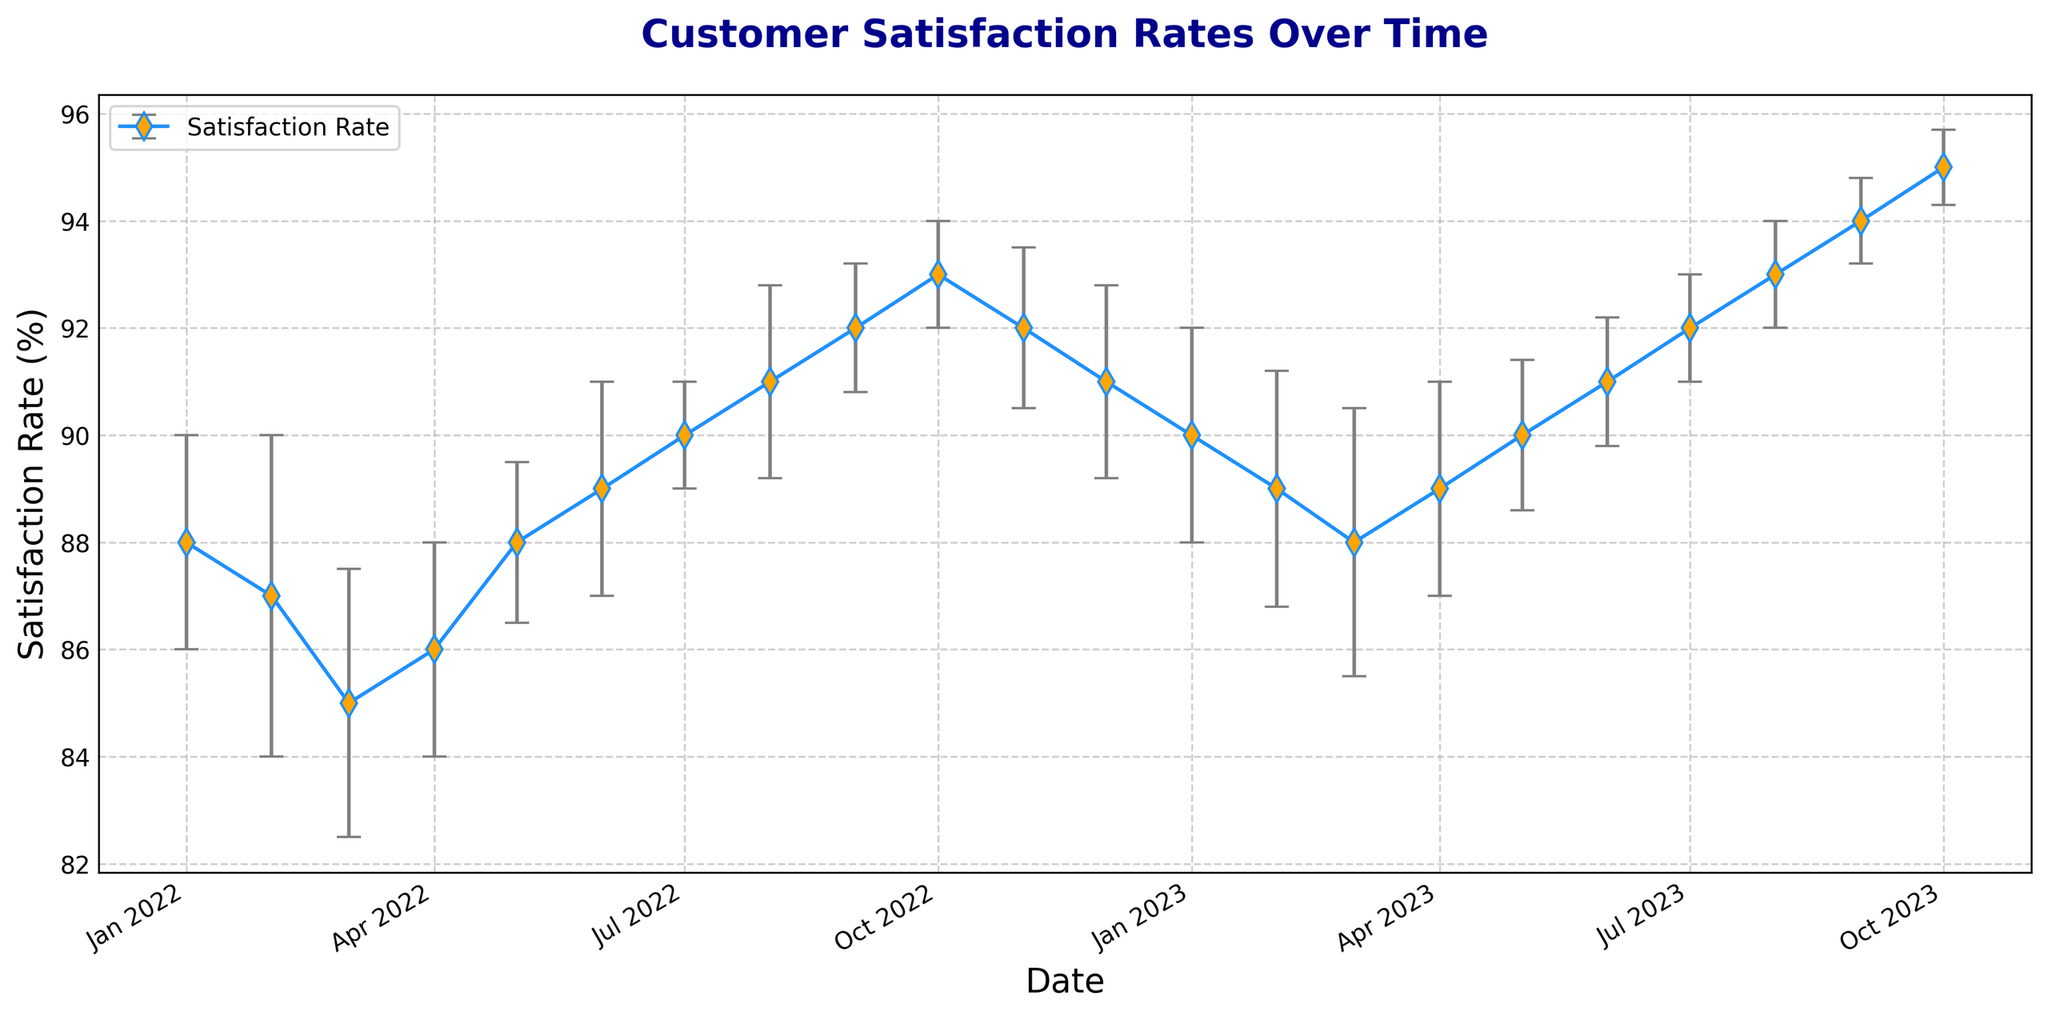Which month had the highest customer satisfaction rate? By observing the highest point on the plot, you can see that October 2023 has the highest satisfaction rate, marked at 95%.
Answer: October 2023 What is the difference between the highest and lowest satisfaction rates? The highest satisfaction rate is 95% in October 2023, and the lowest is 85% in March 2022. The difference is 95% - 85% = 10%.
Answer: 10% What is the average satisfaction rate over the entire period? Sum all the satisfaction rates and divide by the number of data points. The sum is 1907, and there are 21 data points: 1907 / 21 = approximately 90.8%.
Answer: 90.8% In which month did the satisfaction rate first reach 90%? By observing the points on the plot, the first time the satisfaction rate reached 90% was in July 2022.
Answer: July 2022 Between which two consecutive months did the satisfaction rate increase the most? Check the differences between each consecutive month's satisfaction rates. The largest increase is from January 2022 (88%) to February 2022 (87%) which actually decreased. The correct observation is from September 2022 (92%) to October 2022 (93%), a 1 percentage point increase.
Answer: September to October 2022 Is there any overlapping period of confidence intervals between August 2023 and September 2023? Compare the confidence interval ranges for both months: August 2023 is 93% ± 1% (92 to 94), and September 2023 is 94% ± 0.8% (93.2 to 94.8). The ranges overlap between 93.2 to 94.
Answer: Yes Which month saw the smallest confidence interval? By checking the plot, the smallest confidence interval is for October 2023, with a confidence interval of 0.7%.
Answer: October 2023 How much did the satisfaction rate change from January 2022 to January 2023? Subtract the satisfaction rate in January 2022 (88%) from January 2023 (90%): 90% - 88% = 2%.
Answer: 2% 